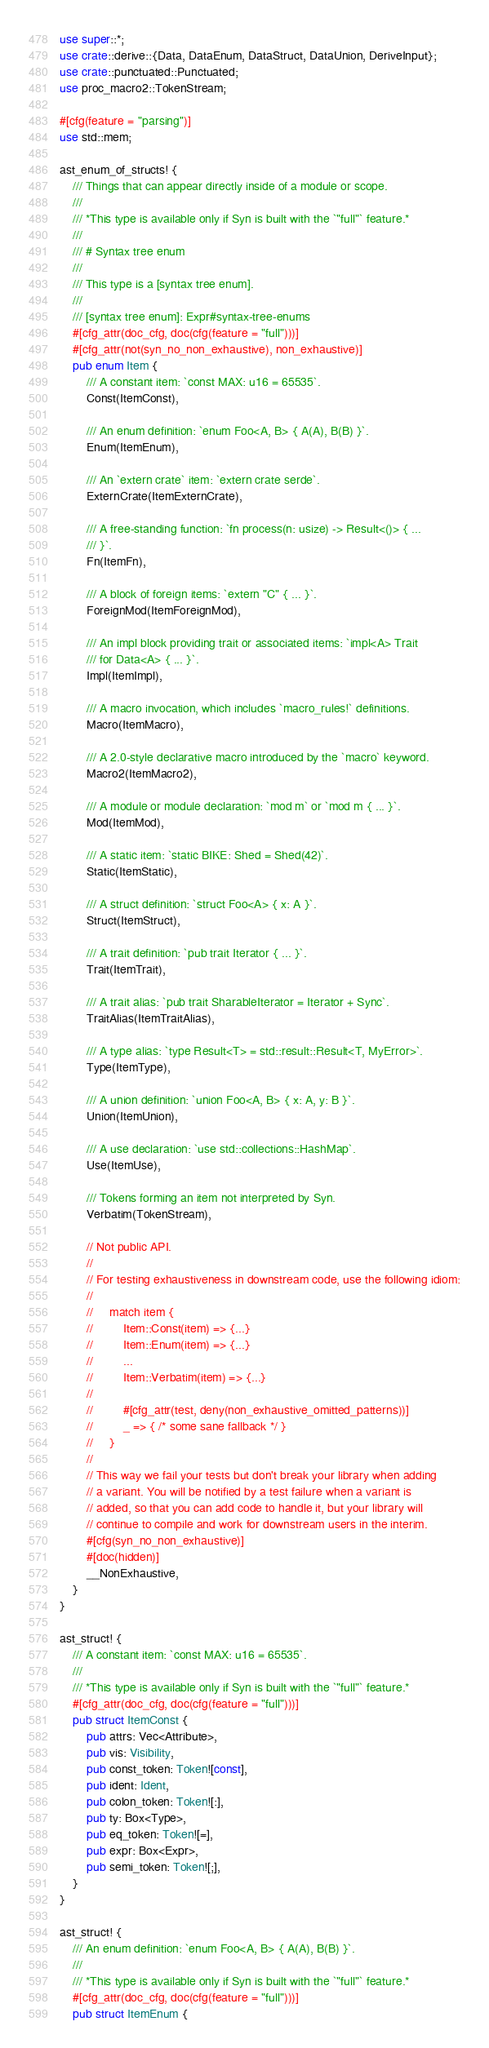Convert code to text. <code><loc_0><loc_0><loc_500><loc_500><_Rust_>use super::*;
use crate::derive::{Data, DataEnum, DataStruct, DataUnion, DeriveInput};
use crate::punctuated::Punctuated;
use proc_macro2::TokenStream;

#[cfg(feature = "parsing")]
use std::mem;

ast_enum_of_structs! {
    /// Things that can appear directly inside of a module or scope.
    ///
    /// *This type is available only if Syn is built with the `"full"` feature.*
    ///
    /// # Syntax tree enum
    ///
    /// This type is a [syntax tree enum].
    ///
    /// [syntax tree enum]: Expr#syntax-tree-enums
    #[cfg_attr(doc_cfg, doc(cfg(feature = "full")))]
    #[cfg_attr(not(syn_no_non_exhaustive), non_exhaustive)]
    pub enum Item {
        /// A constant item: `const MAX: u16 = 65535`.
        Const(ItemConst),

        /// An enum definition: `enum Foo<A, B> { A(A), B(B) }`.
        Enum(ItemEnum),

        /// An `extern crate` item: `extern crate serde`.
        ExternCrate(ItemExternCrate),

        /// A free-standing function: `fn process(n: usize) -> Result<()> { ...
        /// }`.
        Fn(ItemFn),

        /// A block of foreign items: `extern "C" { ... }`.
        ForeignMod(ItemForeignMod),

        /// An impl block providing trait or associated items: `impl<A> Trait
        /// for Data<A> { ... }`.
        Impl(ItemImpl),

        /// A macro invocation, which includes `macro_rules!` definitions.
        Macro(ItemMacro),

        /// A 2.0-style declarative macro introduced by the `macro` keyword.
        Macro2(ItemMacro2),

        /// A module or module declaration: `mod m` or `mod m { ... }`.
        Mod(ItemMod),

        /// A static item: `static BIKE: Shed = Shed(42)`.
        Static(ItemStatic),

        /// A struct definition: `struct Foo<A> { x: A }`.
        Struct(ItemStruct),

        /// A trait definition: `pub trait Iterator { ... }`.
        Trait(ItemTrait),

        /// A trait alias: `pub trait SharableIterator = Iterator + Sync`.
        TraitAlias(ItemTraitAlias),

        /// A type alias: `type Result<T> = std::result::Result<T, MyError>`.
        Type(ItemType),

        /// A union definition: `union Foo<A, B> { x: A, y: B }`.
        Union(ItemUnion),

        /// A use declaration: `use std::collections::HashMap`.
        Use(ItemUse),

        /// Tokens forming an item not interpreted by Syn.
        Verbatim(TokenStream),

        // Not public API.
        //
        // For testing exhaustiveness in downstream code, use the following idiom:
        //
        //     match item {
        //         Item::Const(item) => {...}
        //         Item::Enum(item) => {...}
        //         ...
        //         Item::Verbatim(item) => {...}
        //
        //         #[cfg_attr(test, deny(non_exhaustive_omitted_patterns))]
        //         _ => { /* some sane fallback */ }
        //     }
        //
        // This way we fail your tests but don't break your library when adding
        // a variant. You will be notified by a test failure when a variant is
        // added, so that you can add code to handle it, but your library will
        // continue to compile and work for downstream users in the interim.
        #[cfg(syn_no_non_exhaustive)]
        #[doc(hidden)]
        __NonExhaustive,
    }
}

ast_struct! {
    /// A constant item: `const MAX: u16 = 65535`.
    ///
    /// *This type is available only if Syn is built with the `"full"` feature.*
    #[cfg_attr(doc_cfg, doc(cfg(feature = "full")))]
    pub struct ItemConst {
        pub attrs: Vec<Attribute>,
        pub vis: Visibility,
        pub const_token: Token![const],
        pub ident: Ident,
        pub colon_token: Token![:],
        pub ty: Box<Type>,
        pub eq_token: Token![=],
        pub expr: Box<Expr>,
        pub semi_token: Token![;],
    }
}

ast_struct! {
    /// An enum definition: `enum Foo<A, B> { A(A), B(B) }`.
    ///
    /// *This type is available only if Syn is built with the `"full"` feature.*
    #[cfg_attr(doc_cfg, doc(cfg(feature = "full")))]
    pub struct ItemEnum {</code> 